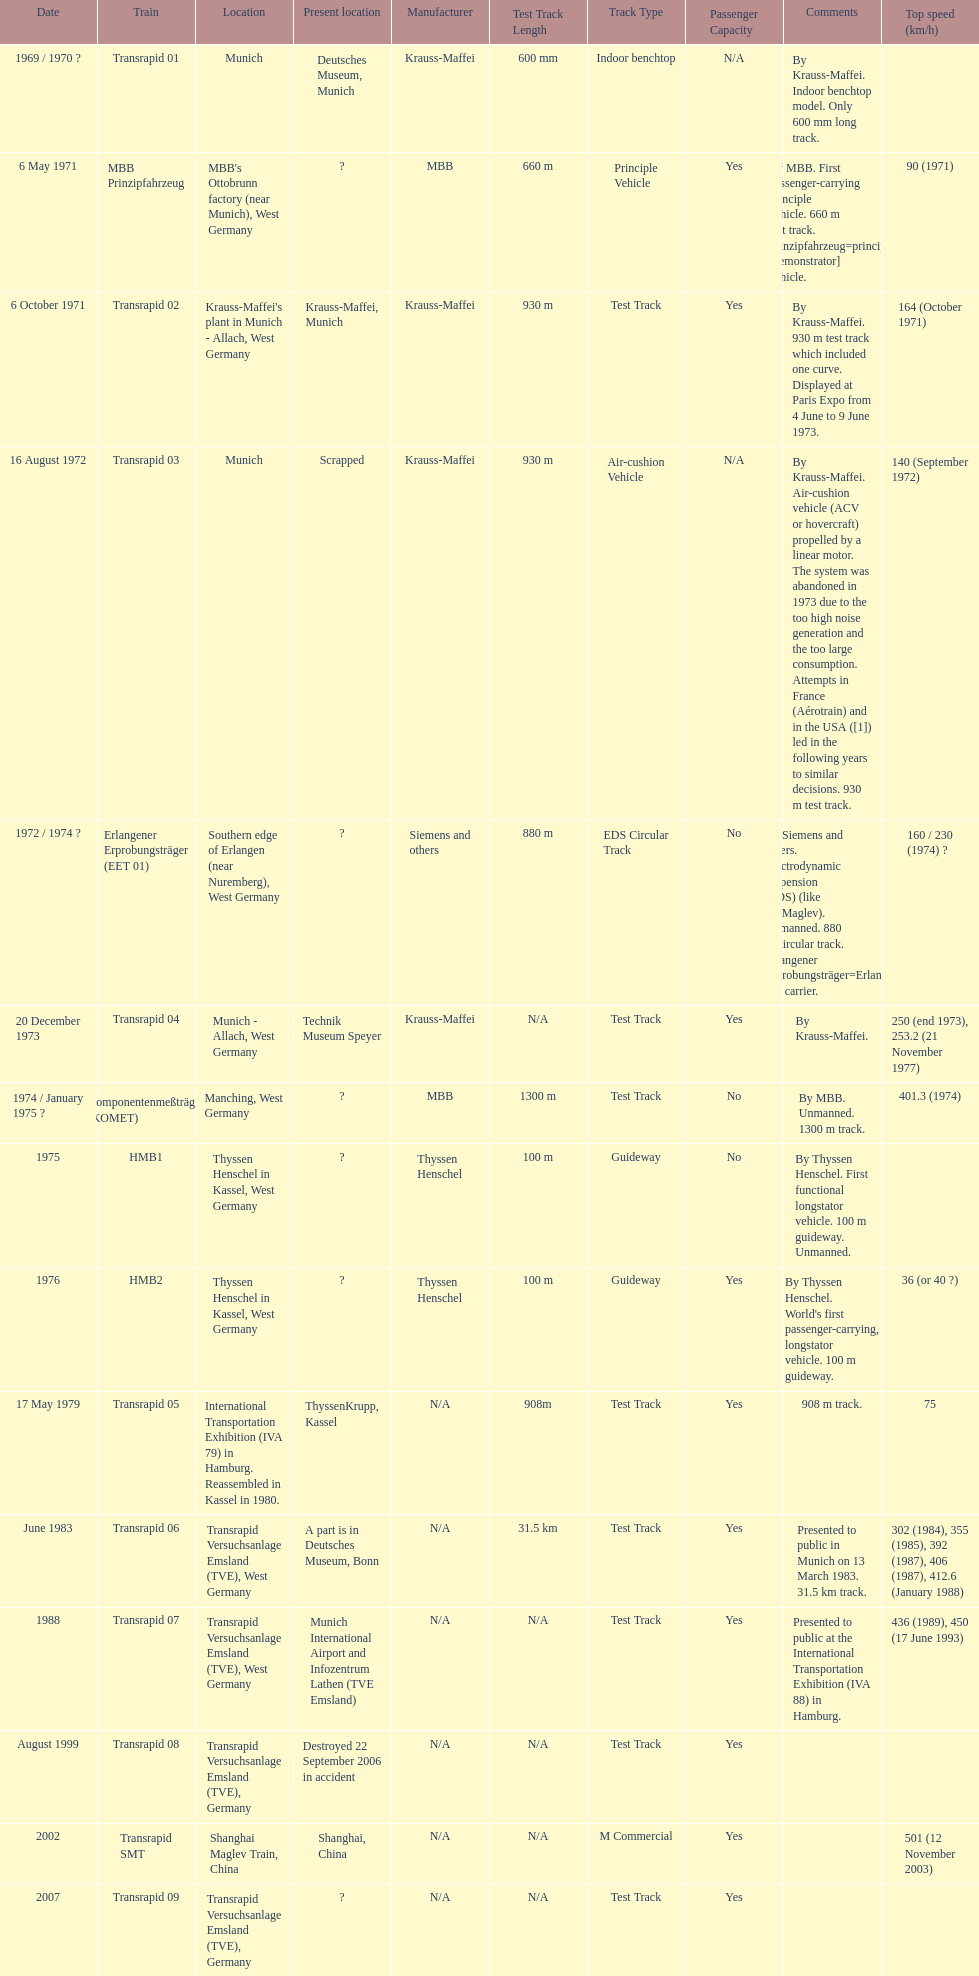How many trains can achieve speeds greater than 450 km/h, excluding the transrapid 07? 1. 